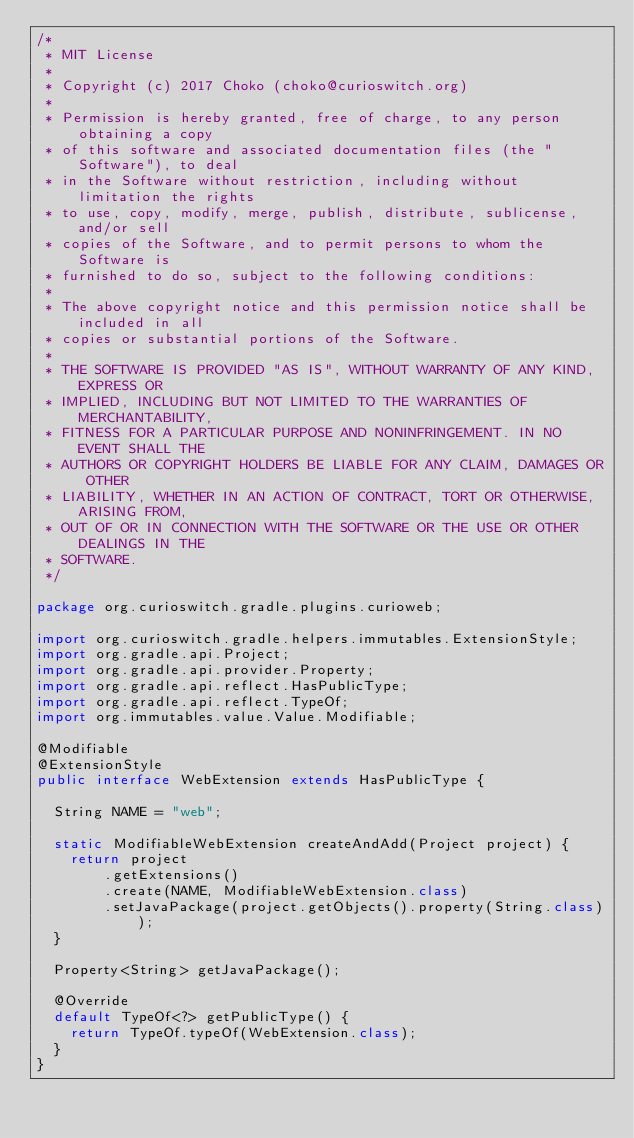Convert code to text. <code><loc_0><loc_0><loc_500><loc_500><_Java_>/*
 * MIT License
 *
 * Copyright (c) 2017 Choko (choko@curioswitch.org)
 *
 * Permission is hereby granted, free of charge, to any person obtaining a copy
 * of this software and associated documentation files (the "Software"), to deal
 * in the Software without restriction, including without limitation the rights
 * to use, copy, modify, merge, publish, distribute, sublicense, and/or sell
 * copies of the Software, and to permit persons to whom the Software is
 * furnished to do so, subject to the following conditions:
 *
 * The above copyright notice and this permission notice shall be included in all
 * copies or substantial portions of the Software.
 *
 * THE SOFTWARE IS PROVIDED "AS IS", WITHOUT WARRANTY OF ANY KIND, EXPRESS OR
 * IMPLIED, INCLUDING BUT NOT LIMITED TO THE WARRANTIES OF MERCHANTABILITY,
 * FITNESS FOR A PARTICULAR PURPOSE AND NONINFRINGEMENT. IN NO EVENT SHALL THE
 * AUTHORS OR COPYRIGHT HOLDERS BE LIABLE FOR ANY CLAIM, DAMAGES OR OTHER
 * LIABILITY, WHETHER IN AN ACTION OF CONTRACT, TORT OR OTHERWISE, ARISING FROM,
 * OUT OF OR IN CONNECTION WITH THE SOFTWARE OR THE USE OR OTHER DEALINGS IN THE
 * SOFTWARE.
 */

package org.curioswitch.gradle.plugins.curioweb;

import org.curioswitch.gradle.helpers.immutables.ExtensionStyle;
import org.gradle.api.Project;
import org.gradle.api.provider.Property;
import org.gradle.api.reflect.HasPublicType;
import org.gradle.api.reflect.TypeOf;
import org.immutables.value.Value.Modifiable;

@Modifiable
@ExtensionStyle
public interface WebExtension extends HasPublicType {

  String NAME = "web";

  static ModifiableWebExtension createAndAdd(Project project) {
    return project
        .getExtensions()
        .create(NAME, ModifiableWebExtension.class)
        .setJavaPackage(project.getObjects().property(String.class));
  }

  Property<String> getJavaPackage();

  @Override
  default TypeOf<?> getPublicType() {
    return TypeOf.typeOf(WebExtension.class);
  }
}
</code> 